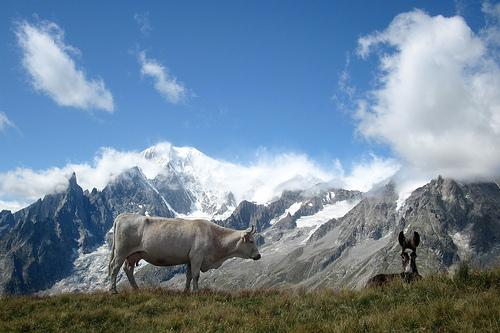Count the total number of animals presented in the image. Four animals: one cow, one donkey, one tan cow, and one horse. What is the primary focus of the image and what is its most distinctive feature? The primary focus is a white cow with black nose on a hill; the cow's face is quite distinctive. List the four prominent animals featured in the picture along with their main colors. White cow, brown and white donkey, white-faced horse with long ears, and a tan cow. Describe the various aspects of the physical appearance of the donkey portrayed in the image. The donkey is brown colored, has a white face with long ears, and a white blaze on its face. For the cow, list down at least six different body parts visible in the image. Head, ear, eye, mouth, tail, back legs, front legs, neck, body, udders. How many mentions of mountains are there in the given information, and what do these mountains generally have on/above them? There are 15 mentions of mountains, generally with snow on their tops or white clouds above them. Analyze the overall sentiment and mood of the image. The image has a peaceful, tranquil mood, with animals on hills and beautiful mountains in the background. Mention the color and condition of the grass in the foreground. The grass is green and brown, appearing a bit dry. In the image, describe the notable features of the sky and the mountains. The sky has white fluffy clouds in a clear blue expanse, while the mountains have craggy peaks covered with snow. Explain the interaction between the cow and the donkey in the image. The cow is looking at the donkey, suggesting some curiosity or possible communication between the two animals. Indicate the species of the animal with long ears and a white face blaze. Horse Can you find a bird flying in the clear blue sky? There is no mention of a bird in any of the captions. The sky is described as being "clear blue" with "white fluffy clouds," but there is no mention of any birds. What does the cow look at in the image? The cow is looking at the donkey. Are there any flowers growing in the foreground grass? There is no mention of flowers in any of the captions. The grass is described as being "green and brown" and "a bit dry," but there is no mention of any flowers growing in it. What is located at X:341 Y:18 in the image? A fluffy cloud in the sky Describe the physical attributes of the cow in the image. The cow is white, has a black nose, and has milk udders. Identify the animal species present in the given image. Cow and donkey Find any text present in the image. There is no text in the image. Point out any unusual or unexpected element in the image. There are no obvious anomalies in the image. Can you see a goat with long ears in the image? There is no mention of a goat in any of the captions. There is a donkey with long ears, but not a goat. List the main components of the background. Mountains with snow, cloudy blue sky Is there a black cow standing on the hill? There is no mention of a black cow in any of the captions. There is a white cow, but not a black one. Do the mountains have green trees on them? There is no mention of green trees on the mountains in any of the captions. The mountains are described as "craggy," "snow-capped," "above the tree line," and "rocky," but there are no references to trees on them. Is there any snow in the image? Yes, there is snow on the mountain tops. Describe the main objects in the image. There is a white cow, a brown and white donkey, grass in the foreground, mountains with snow, and blue sky with clouds. Rate the quality of the image from 1 to 10, with 1 being poor and 10 being excellent. 8 Which color is more prominent in the grass, green or brown? Green Describe the condition of the grass in the image. The grass is green and brown, and looks a bit dry. Determine the emotion conveyed by the scene in the image. The image conveys a feeling of serenity and peacefulness. Discuss the type of clouds in the sky. There are white fluffy clouds in a clear blue sky. What is the most striking feature of the donkey's face? The donkey has a brown and white face with long ears. What part of the cow can be found at X:227 Y:215? the head of a cow Describe the interaction between the cow and the donkey. The cow is looking at the donkey, and they seem to be peacefully coexisting on the hill. What type of landscape is the image showing? Mountainous landscape with grassy hills Is there a river flowing through the landscape? No, it's not mentioned in the image. 